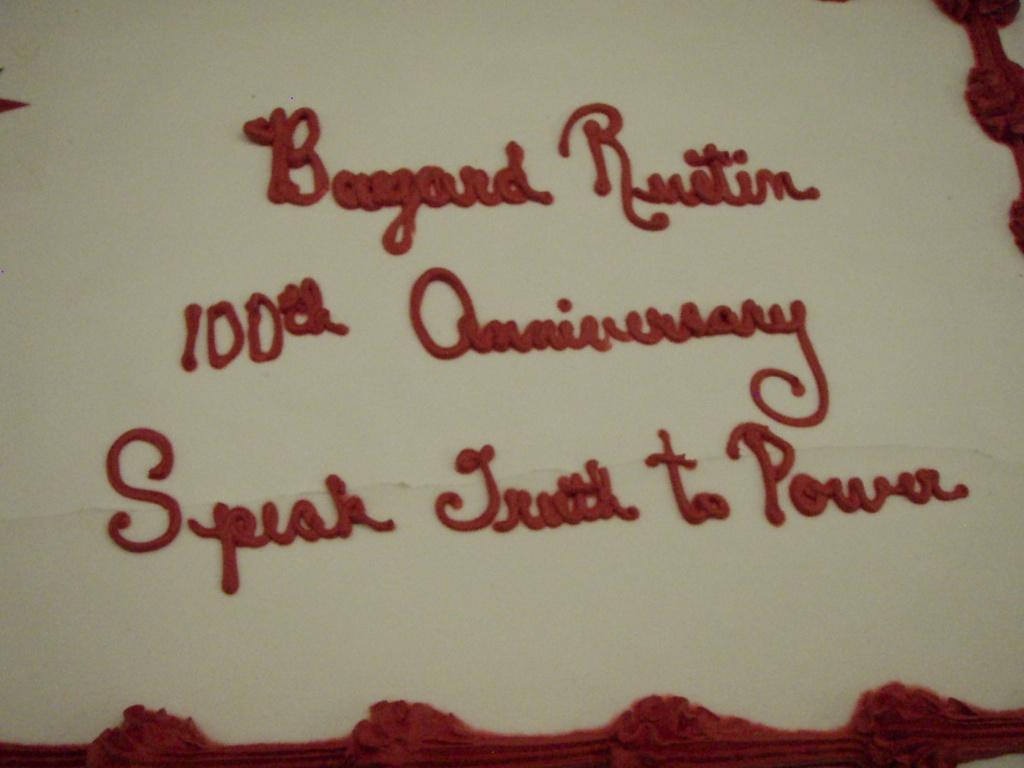Please provide a concise description of this image. This image consists of a white color cake on which I can see some red color text. 